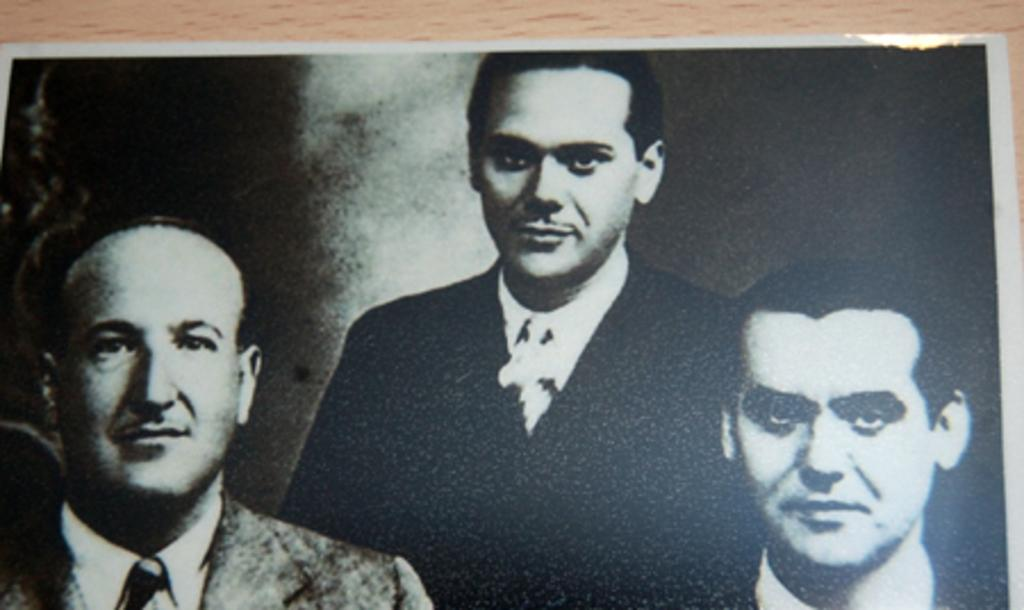How many people are in the image? There are three men in the image. What can be observed about the color scheme of the image? The image is black and white. What type of muscle is being flexed by the man on the left in the image? There is no indication of any muscles being flexed in the image, as it is a black and white image of three men. What kind of plant can be seen growing in the background of the image? There is no plant visible in the image, as it is a black and white image of three men. 